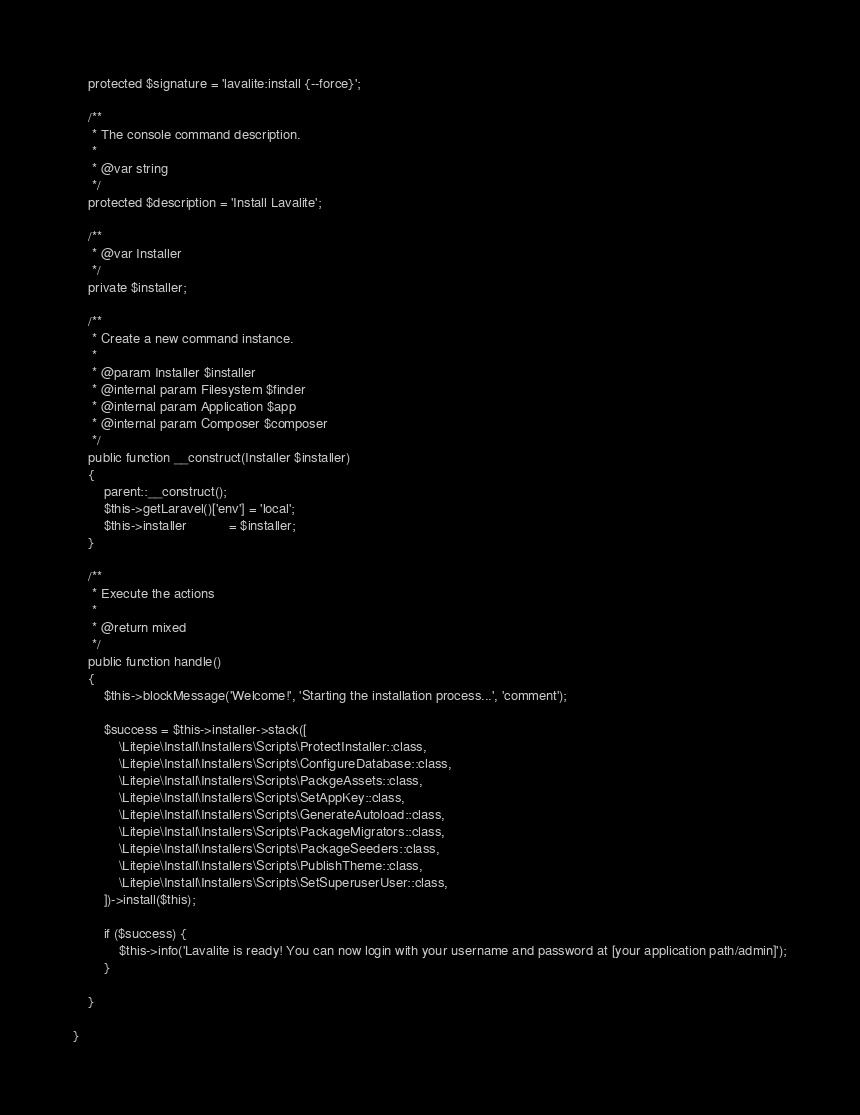Convert code to text. <code><loc_0><loc_0><loc_500><loc_500><_PHP_>    protected $signature = 'lavalite:install {--force}';

    /**
     * The console command description.
     *
     * @var string
     */
    protected $description = 'Install Lavalite';

    /**
     * @var Installer
     */
    private $installer;

    /**
     * Create a new command instance.
     *
     * @param Installer $installer
     * @internal param Filesystem $finder
     * @internal param Application $app
     * @internal param Composer $composer
     */
    public function __construct(Installer $installer)
    {
        parent::__construct();
        $this->getLaravel()['env'] = 'local';
        $this->installer           = $installer;
    }

    /**
     * Execute the actions
     *
     * @return mixed
     */
    public function handle()
    {
        $this->blockMessage('Welcome!', 'Starting the installation process...', 'comment');

        $success = $this->installer->stack([
            \Litepie\Install\Installers\Scripts\ProtectInstaller::class,
            \Litepie\Install\Installers\Scripts\ConfigureDatabase::class,
            \Litepie\Install\Installers\Scripts\PackgeAssets::class,
            \Litepie\Install\Installers\Scripts\SetAppKey::class,
            \Litepie\Install\Installers\Scripts\GenerateAutoload::class,
            \Litepie\Install\Installers\Scripts\PackageMigrators::class,
            \Litepie\Install\Installers\Scripts\PackageSeeders::class,
            \Litepie\Install\Installers\Scripts\PublishTheme::class,
            \Litepie\Install\Installers\Scripts\SetSuperuserUser::class,
        ])->install($this);

        if ($success) {
            $this->info('Lavalite is ready! You can now login with your username and password at [your application path/admin]');
        }

    }

}
</code> 